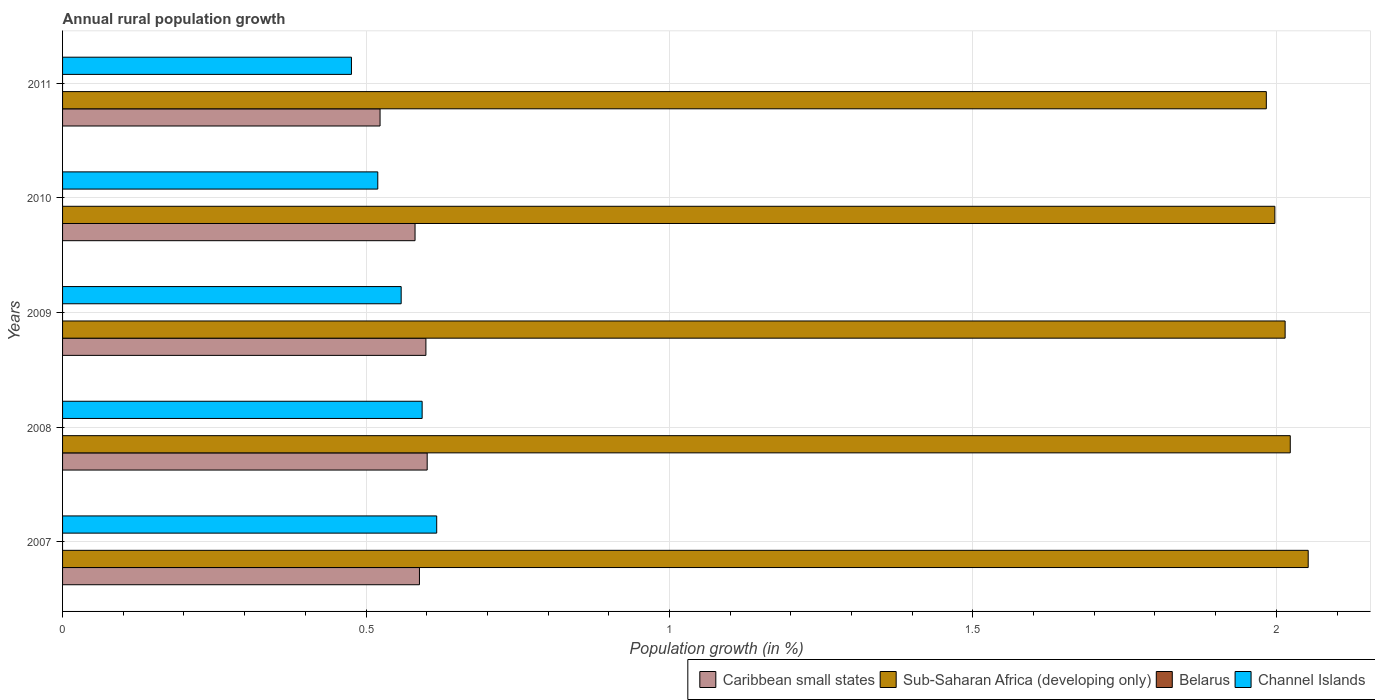Are the number of bars per tick equal to the number of legend labels?
Provide a short and direct response. No. How many bars are there on the 2nd tick from the bottom?
Your answer should be very brief. 3. What is the percentage of rural population growth in Sub-Saharan Africa (developing only) in 2007?
Offer a very short reply. 2.05. Across all years, what is the maximum percentage of rural population growth in Caribbean small states?
Give a very brief answer. 0.6. Across all years, what is the minimum percentage of rural population growth in Sub-Saharan Africa (developing only)?
Offer a terse response. 1.98. In which year was the percentage of rural population growth in Channel Islands maximum?
Offer a terse response. 2007. What is the total percentage of rural population growth in Caribbean small states in the graph?
Provide a short and direct response. 2.89. What is the difference between the percentage of rural population growth in Channel Islands in 2007 and that in 2010?
Your answer should be very brief. 0.1. What is the difference between the percentage of rural population growth in Belarus in 2011 and the percentage of rural population growth in Sub-Saharan Africa (developing only) in 2007?
Your response must be concise. -2.05. What is the average percentage of rural population growth in Sub-Saharan Africa (developing only) per year?
Make the answer very short. 2.01. In the year 2010, what is the difference between the percentage of rural population growth in Sub-Saharan Africa (developing only) and percentage of rural population growth in Caribbean small states?
Ensure brevity in your answer.  1.42. What is the ratio of the percentage of rural population growth in Channel Islands in 2007 to that in 2011?
Your answer should be compact. 1.3. Is the difference between the percentage of rural population growth in Sub-Saharan Africa (developing only) in 2007 and 2009 greater than the difference between the percentage of rural population growth in Caribbean small states in 2007 and 2009?
Offer a very short reply. Yes. What is the difference between the highest and the second highest percentage of rural population growth in Sub-Saharan Africa (developing only)?
Keep it short and to the point. 0.03. What is the difference between the highest and the lowest percentage of rural population growth in Channel Islands?
Make the answer very short. 0.14. In how many years, is the percentage of rural population growth in Belarus greater than the average percentage of rural population growth in Belarus taken over all years?
Provide a succinct answer. 0. Is it the case that in every year, the sum of the percentage of rural population growth in Sub-Saharan Africa (developing only) and percentage of rural population growth in Caribbean small states is greater than the sum of percentage of rural population growth in Belarus and percentage of rural population growth in Channel Islands?
Keep it short and to the point. Yes. Is it the case that in every year, the sum of the percentage of rural population growth in Caribbean small states and percentage of rural population growth in Channel Islands is greater than the percentage of rural population growth in Belarus?
Ensure brevity in your answer.  Yes. Are all the bars in the graph horizontal?
Give a very brief answer. Yes. How many years are there in the graph?
Your response must be concise. 5. What is the difference between two consecutive major ticks on the X-axis?
Provide a short and direct response. 0.5. What is the title of the graph?
Ensure brevity in your answer.  Annual rural population growth. Does "St. Vincent and the Grenadines" appear as one of the legend labels in the graph?
Provide a short and direct response. No. What is the label or title of the X-axis?
Your response must be concise. Population growth (in %). What is the label or title of the Y-axis?
Offer a very short reply. Years. What is the Population growth (in %) in Caribbean small states in 2007?
Your response must be concise. 0.59. What is the Population growth (in %) in Sub-Saharan Africa (developing only) in 2007?
Give a very brief answer. 2.05. What is the Population growth (in %) of Channel Islands in 2007?
Offer a terse response. 0.62. What is the Population growth (in %) of Caribbean small states in 2008?
Give a very brief answer. 0.6. What is the Population growth (in %) of Sub-Saharan Africa (developing only) in 2008?
Ensure brevity in your answer.  2.02. What is the Population growth (in %) of Belarus in 2008?
Offer a very short reply. 0. What is the Population growth (in %) in Channel Islands in 2008?
Provide a short and direct response. 0.59. What is the Population growth (in %) in Caribbean small states in 2009?
Provide a succinct answer. 0.6. What is the Population growth (in %) in Sub-Saharan Africa (developing only) in 2009?
Keep it short and to the point. 2.01. What is the Population growth (in %) in Belarus in 2009?
Your answer should be compact. 0. What is the Population growth (in %) in Channel Islands in 2009?
Offer a very short reply. 0.56. What is the Population growth (in %) in Caribbean small states in 2010?
Keep it short and to the point. 0.58. What is the Population growth (in %) in Sub-Saharan Africa (developing only) in 2010?
Provide a succinct answer. 2. What is the Population growth (in %) of Belarus in 2010?
Offer a very short reply. 0. What is the Population growth (in %) of Channel Islands in 2010?
Keep it short and to the point. 0.52. What is the Population growth (in %) in Caribbean small states in 2011?
Provide a short and direct response. 0.52. What is the Population growth (in %) of Sub-Saharan Africa (developing only) in 2011?
Your answer should be compact. 1.98. What is the Population growth (in %) of Belarus in 2011?
Provide a short and direct response. 0. What is the Population growth (in %) of Channel Islands in 2011?
Your answer should be compact. 0.48. Across all years, what is the maximum Population growth (in %) of Caribbean small states?
Your response must be concise. 0.6. Across all years, what is the maximum Population growth (in %) of Sub-Saharan Africa (developing only)?
Make the answer very short. 2.05. Across all years, what is the maximum Population growth (in %) in Channel Islands?
Give a very brief answer. 0.62. Across all years, what is the minimum Population growth (in %) of Caribbean small states?
Your answer should be very brief. 0.52. Across all years, what is the minimum Population growth (in %) of Sub-Saharan Africa (developing only)?
Your response must be concise. 1.98. Across all years, what is the minimum Population growth (in %) of Channel Islands?
Your answer should be very brief. 0.48. What is the total Population growth (in %) of Caribbean small states in the graph?
Offer a very short reply. 2.89. What is the total Population growth (in %) of Sub-Saharan Africa (developing only) in the graph?
Keep it short and to the point. 10.07. What is the total Population growth (in %) in Belarus in the graph?
Ensure brevity in your answer.  0. What is the total Population growth (in %) in Channel Islands in the graph?
Provide a succinct answer. 2.76. What is the difference between the Population growth (in %) in Caribbean small states in 2007 and that in 2008?
Your response must be concise. -0.01. What is the difference between the Population growth (in %) of Sub-Saharan Africa (developing only) in 2007 and that in 2008?
Provide a short and direct response. 0.03. What is the difference between the Population growth (in %) of Channel Islands in 2007 and that in 2008?
Provide a short and direct response. 0.02. What is the difference between the Population growth (in %) in Caribbean small states in 2007 and that in 2009?
Offer a terse response. -0.01. What is the difference between the Population growth (in %) in Sub-Saharan Africa (developing only) in 2007 and that in 2009?
Give a very brief answer. 0.04. What is the difference between the Population growth (in %) of Channel Islands in 2007 and that in 2009?
Offer a terse response. 0.06. What is the difference between the Population growth (in %) in Caribbean small states in 2007 and that in 2010?
Keep it short and to the point. 0.01. What is the difference between the Population growth (in %) of Sub-Saharan Africa (developing only) in 2007 and that in 2010?
Provide a succinct answer. 0.06. What is the difference between the Population growth (in %) in Channel Islands in 2007 and that in 2010?
Your answer should be compact. 0.1. What is the difference between the Population growth (in %) of Caribbean small states in 2007 and that in 2011?
Your answer should be compact. 0.06. What is the difference between the Population growth (in %) in Sub-Saharan Africa (developing only) in 2007 and that in 2011?
Offer a terse response. 0.07. What is the difference between the Population growth (in %) of Channel Islands in 2007 and that in 2011?
Your answer should be compact. 0.14. What is the difference between the Population growth (in %) of Caribbean small states in 2008 and that in 2009?
Offer a very short reply. 0. What is the difference between the Population growth (in %) of Sub-Saharan Africa (developing only) in 2008 and that in 2009?
Ensure brevity in your answer.  0.01. What is the difference between the Population growth (in %) of Channel Islands in 2008 and that in 2009?
Provide a short and direct response. 0.03. What is the difference between the Population growth (in %) in Caribbean small states in 2008 and that in 2010?
Offer a very short reply. 0.02. What is the difference between the Population growth (in %) of Sub-Saharan Africa (developing only) in 2008 and that in 2010?
Provide a short and direct response. 0.03. What is the difference between the Population growth (in %) in Channel Islands in 2008 and that in 2010?
Offer a very short reply. 0.07. What is the difference between the Population growth (in %) of Caribbean small states in 2008 and that in 2011?
Make the answer very short. 0.08. What is the difference between the Population growth (in %) in Sub-Saharan Africa (developing only) in 2008 and that in 2011?
Offer a very short reply. 0.04. What is the difference between the Population growth (in %) of Channel Islands in 2008 and that in 2011?
Offer a terse response. 0.12. What is the difference between the Population growth (in %) of Caribbean small states in 2009 and that in 2010?
Provide a short and direct response. 0.02. What is the difference between the Population growth (in %) of Sub-Saharan Africa (developing only) in 2009 and that in 2010?
Give a very brief answer. 0.02. What is the difference between the Population growth (in %) of Channel Islands in 2009 and that in 2010?
Make the answer very short. 0.04. What is the difference between the Population growth (in %) in Caribbean small states in 2009 and that in 2011?
Give a very brief answer. 0.08. What is the difference between the Population growth (in %) of Sub-Saharan Africa (developing only) in 2009 and that in 2011?
Ensure brevity in your answer.  0.03. What is the difference between the Population growth (in %) in Channel Islands in 2009 and that in 2011?
Offer a terse response. 0.08. What is the difference between the Population growth (in %) in Caribbean small states in 2010 and that in 2011?
Offer a terse response. 0.06. What is the difference between the Population growth (in %) in Sub-Saharan Africa (developing only) in 2010 and that in 2011?
Your answer should be compact. 0.01. What is the difference between the Population growth (in %) of Channel Islands in 2010 and that in 2011?
Keep it short and to the point. 0.04. What is the difference between the Population growth (in %) in Caribbean small states in 2007 and the Population growth (in %) in Sub-Saharan Africa (developing only) in 2008?
Your answer should be very brief. -1.43. What is the difference between the Population growth (in %) in Caribbean small states in 2007 and the Population growth (in %) in Channel Islands in 2008?
Offer a terse response. -0. What is the difference between the Population growth (in %) of Sub-Saharan Africa (developing only) in 2007 and the Population growth (in %) of Channel Islands in 2008?
Your answer should be compact. 1.46. What is the difference between the Population growth (in %) of Caribbean small states in 2007 and the Population growth (in %) of Sub-Saharan Africa (developing only) in 2009?
Your response must be concise. -1.43. What is the difference between the Population growth (in %) in Caribbean small states in 2007 and the Population growth (in %) in Channel Islands in 2009?
Keep it short and to the point. 0.03. What is the difference between the Population growth (in %) in Sub-Saharan Africa (developing only) in 2007 and the Population growth (in %) in Channel Islands in 2009?
Keep it short and to the point. 1.49. What is the difference between the Population growth (in %) of Caribbean small states in 2007 and the Population growth (in %) of Sub-Saharan Africa (developing only) in 2010?
Your answer should be compact. -1.41. What is the difference between the Population growth (in %) of Caribbean small states in 2007 and the Population growth (in %) of Channel Islands in 2010?
Offer a very short reply. 0.07. What is the difference between the Population growth (in %) in Sub-Saharan Africa (developing only) in 2007 and the Population growth (in %) in Channel Islands in 2010?
Your answer should be very brief. 1.53. What is the difference between the Population growth (in %) in Caribbean small states in 2007 and the Population growth (in %) in Sub-Saharan Africa (developing only) in 2011?
Offer a very short reply. -1.4. What is the difference between the Population growth (in %) of Caribbean small states in 2007 and the Population growth (in %) of Channel Islands in 2011?
Your answer should be very brief. 0.11. What is the difference between the Population growth (in %) of Sub-Saharan Africa (developing only) in 2007 and the Population growth (in %) of Channel Islands in 2011?
Your answer should be compact. 1.58. What is the difference between the Population growth (in %) of Caribbean small states in 2008 and the Population growth (in %) of Sub-Saharan Africa (developing only) in 2009?
Your answer should be very brief. -1.41. What is the difference between the Population growth (in %) in Caribbean small states in 2008 and the Population growth (in %) in Channel Islands in 2009?
Offer a very short reply. 0.04. What is the difference between the Population growth (in %) in Sub-Saharan Africa (developing only) in 2008 and the Population growth (in %) in Channel Islands in 2009?
Offer a very short reply. 1.47. What is the difference between the Population growth (in %) in Caribbean small states in 2008 and the Population growth (in %) in Sub-Saharan Africa (developing only) in 2010?
Offer a very short reply. -1.4. What is the difference between the Population growth (in %) of Caribbean small states in 2008 and the Population growth (in %) of Channel Islands in 2010?
Offer a terse response. 0.08. What is the difference between the Population growth (in %) of Sub-Saharan Africa (developing only) in 2008 and the Population growth (in %) of Channel Islands in 2010?
Provide a short and direct response. 1.5. What is the difference between the Population growth (in %) in Caribbean small states in 2008 and the Population growth (in %) in Sub-Saharan Africa (developing only) in 2011?
Your response must be concise. -1.38. What is the difference between the Population growth (in %) of Caribbean small states in 2008 and the Population growth (in %) of Channel Islands in 2011?
Ensure brevity in your answer.  0.12. What is the difference between the Population growth (in %) in Sub-Saharan Africa (developing only) in 2008 and the Population growth (in %) in Channel Islands in 2011?
Your answer should be compact. 1.55. What is the difference between the Population growth (in %) of Caribbean small states in 2009 and the Population growth (in %) of Sub-Saharan Africa (developing only) in 2010?
Make the answer very short. -1.4. What is the difference between the Population growth (in %) in Caribbean small states in 2009 and the Population growth (in %) in Channel Islands in 2010?
Keep it short and to the point. 0.08. What is the difference between the Population growth (in %) of Sub-Saharan Africa (developing only) in 2009 and the Population growth (in %) of Channel Islands in 2010?
Make the answer very short. 1.5. What is the difference between the Population growth (in %) in Caribbean small states in 2009 and the Population growth (in %) in Sub-Saharan Africa (developing only) in 2011?
Offer a very short reply. -1.38. What is the difference between the Population growth (in %) in Caribbean small states in 2009 and the Population growth (in %) in Channel Islands in 2011?
Offer a very short reply. 0.12. What is the difference between the Population growth (in %) in Sub-Saharan Africa (developing only) in 2009 and the Population growth (in %) in Channel Islands in 2011?
Offer a terse response. 1.54. What is the difference between the Population growth (in %) of Caribbean small states in 2010 and the Population growth (in %) of Sub-Saharan Africa (developing only) in 2011?
Your answer should be compact. -1.4. What is the difference between the Population growth (in %) of Caribbean small states in 2010 and the Population growth (in %) of Channel Islands in 2011?
Your response must be concise. 0.1. What is the difference between the Population growth (in %) of Sub-Saharan Africa (developing only) in 2010 and the Population growth (in %) of Channel Islands in 2011?
Your answer should be very brief. 1.52. What is the average Population growth (in %) of Caribbean small states per year?
Offer a very short reply. 0.58. What is the average Population growth (in %) in Sub-Saharan Africa (developing only) per year?
Make the answer very short. 2.01. What is the average Population growth (in %) of Belarus per year?
Your answer should be compact. 0. What is the average Population growth (in %) of Channel Islands per year?
Provide a short and direct response. 0.55. In the year 2007, what is the difference between the Population growth (in %) in Caribbean small states and Population growth (in %) in Sub-Saharan Africa (developing only)?
Your response must be concise. -1.46. In the year 2007, what is the difference between the Population growth (in %) of Caribbean small states and Population growth (in %) of Channel Islands?
Provide a short and direct response. -0.03. In the year 2007, what is the difference between the Population growth (in %) in Sub-Saharan Africa (developing only) and Population growth (in %) in Channel Islands?
Offer a very short reply. 1.44. In the year 2008, what is the difference between the Population growth (in %) in Caribbean small states and Population growth (in %) in Sub-Saharan Africa (developing only)?
Offer a terse response. -1.42. In the year 2008, what is the difference between the Population growth (in %) of Caribbean small states and Population growth (in %) of Channel Islands?
Offer a terse response. 0.01. In the year 2008, what is the difference between the Population growth (in %) of Sub-Saharan Africa (developing only) and Population growth (in %) of Channel Islands?
Make the answer very short. 1.43. In the year 2009, what is the difference between the Population growth (in %) of Caribbean small states and Population growth (in %) of Sub-Saharan Africa (developing only)?
Give a very brief answer. -1.42. In the year 2009, what is the difference between the Population growth (in %) of Caribbean small states and Population growth (in %) of Channel Islands?
Make the answer very short. 0.04. In the year 2009, what is the difference between the Population growth (in %) in Sub-Saharan Africa (developing only) and Population growth (in %) in Channel Islands?
Your response must be concise. 1.46. In the year 2010, what is the difference between the Population growth (in %) in Caribbean small states and Population growth (in %) in Sub-Saharan Africa (developing only)?
Provide a short and direct response. -1.42. In the year 2010, what is the difference between the Population growth (in %) in Caribbean small states and Population growth (in %) in Channel Islands?
Keep it short and to the point. 0.06. In the year 2010, what is the difference between the Population growth (in %) of Sub-Saharan Africa (developing only) and Population growth (in %) of Channel Islands?
Your answer should be compact. 1.48. In the year 2011, what is the difference between the Population growth (in %) of Caribbean small states and Population growth (in %) of Sub-Saharan Africa (developing only)?
Provide a short and direct response. -1.46. In the year 2011, what is the difference between the Population growth (in %) in Caribbean small states and Population growth (in %) in Channel Islands?
Ensure brevity in your answer.  0.05. In the year 2011, what is the difference between the Population growth (in %) of Sub-Saharan Africa (developing only) and Population growth (in %) of Channel Islands?
Offer a very short reply. 1.51. What is the ratio of the Population growth (in %) in Caribbean small states in 2007 to that in 2008?
Ensure brevity in your answer.  0.98. What is the ratio of the Population growth (in %) of Sub-Saharan Africa (developing only) in 2007 to that in 2008?
Offer a terse response. 1.01. What is the ratio of the Population growth (in %) of Channel Islands in 2007 to that in 2008?
Make the answer very short. 1.04. What is the ratio of the Population growth (in %) of Caribbean small states in 2007 to that in 2009?
Your answer should be compact. 0.98. What is the ratio of the Population growth (in %) of Sub-Saharan Africa (developing only) in 2007 to that in 2009?
Give a very brief answer. 1.02. What is the ratio of the Population growth (in %) of Channel Islands in 2007 to that in 2009?
Your answer should be very brief. 1.1. What is the ratio of the Population growth (in %) of Caribbean small states in 2007 to that in 2010?
Provide a succinct answer. 1.01. What is the ratio of the Population growth (in %) in Sub-Saharan Africa (developing only) in 2007 to that in 2010?
Give a very brief answer. 1.03. What is the ratio of the Population growth (in %) in Channel Islands in 2007 to that in 2010?
Ensure brevity in your answer.  1.19. What is the ratio of the Population growth (in %) in Caribbean small states in 2007 to that in 2011?
Offer a very short reply. 1.12. What is the ratio of the Population growth (in %) in Sub-Saharan Africa (developing only) in 2007 to that in 2011?
Ensure brevity in your answer.  1.03. What is the ratio of the Population growth (in %) in Channel Islands in 2007 to that in 2011?
Keep it short and to the point. 1.29. What is the ratio of the Population growth (in %) of Channel Islands in 2008 to that in 2009?
Your response must be concise. 1.06. What is the ratio of the Population growth (in %) of Caribbean small states in 2008 to that in 2010?
Provide a short and direct response. 1.03. What is the ratio of the Population growth (in %) in Sub-Saharan Africa (developing only) in 2008 to that in 2010?
Make the answer very short. 1.01. What is the ratio of the Population growth (in %) of Channel Islands in 2008 to that in 2010?
Your response must be concise. 1.14. What is the ratio of the Population growth (in %) in Caribbean small states in 2008 to that in 2011?
Your response must be concise. 1.15. What is the ratio of the Population growth (in %) of Sub-Saharan Africa (developing only) in 2008 to that in 2011?
Your answer should be compact. 1.02. What is the ratio of the Population growth (in %) of Channel Islands in 2008 to that in 2011?
Make the answer very short. 1.24. What is the ratio of the Population growth (in %) in Caribbean small states in 2009 to that in 2010?
Offer a very short reply. 1.03. What is the ratio of the Population growth (in %) in Sub-Saharan Africa (developing only) in 2009 to that in 2010?
Give a very brief answer. 1.01. What is the ratio of the Population growth (in %) of Channel Islands in 2009 to that in 2010?
Your answer should be very brief. 1.07. What is the ratio of the Population growth (in %) of Caribbean small states in 2009 to that in 2011?
Provide a short and direct response. 1.14. What is the ratio of the Population growth (in %) in Sub-Saharan Africa (developing only) in 2009 to that in 2011?
Keep it short and to the point. 1.02. What is the ratio of the Population growth (in %) of Channel Islands in 2009 to that in 2011?
Offer a very short reply. 1.17. What is the ratio of the Population growth (in %) in Caribbean small states in 2010 to that in 2011?
Provide a succinct answer. 1.11. What is the ratio of the Population growth (in %) of Sub-Saharan Africa (developing only) in 2010 to that in 2011?
Make the answer very short. 1.01. What is the ratio of the Population growth (in %) of Channel Islands in 2010 to that in 2011?
Offer a very short reply. 1.09. What is the difference between the highest and the second highest Population growth (in %) in Caribbean small states?
Your answer should be very brief. 0. What is the difference between the highest and the second highest Population growth (in %) in Sub-Saharan Africa (developing only)?
Your answer should be compact. 0.03. What is the difference between the highest and the second highest Population growth (in %) in Channel Islands?
Ensure brevity in your answer.  0.02. What is the difference between the highest and the lowest Population growth (in %) in Caribbean small states?
Offer a very short reply. 0.08. What is the difference between the highest and the lowest Population growth (in %) of Sub-Saharan Africa (developing only)?
Make the answer very short. 0.07. What is the difference between the highest and the lowest Population growth (in %) of Channel Islands?
Make the answer very short. 0.14. 